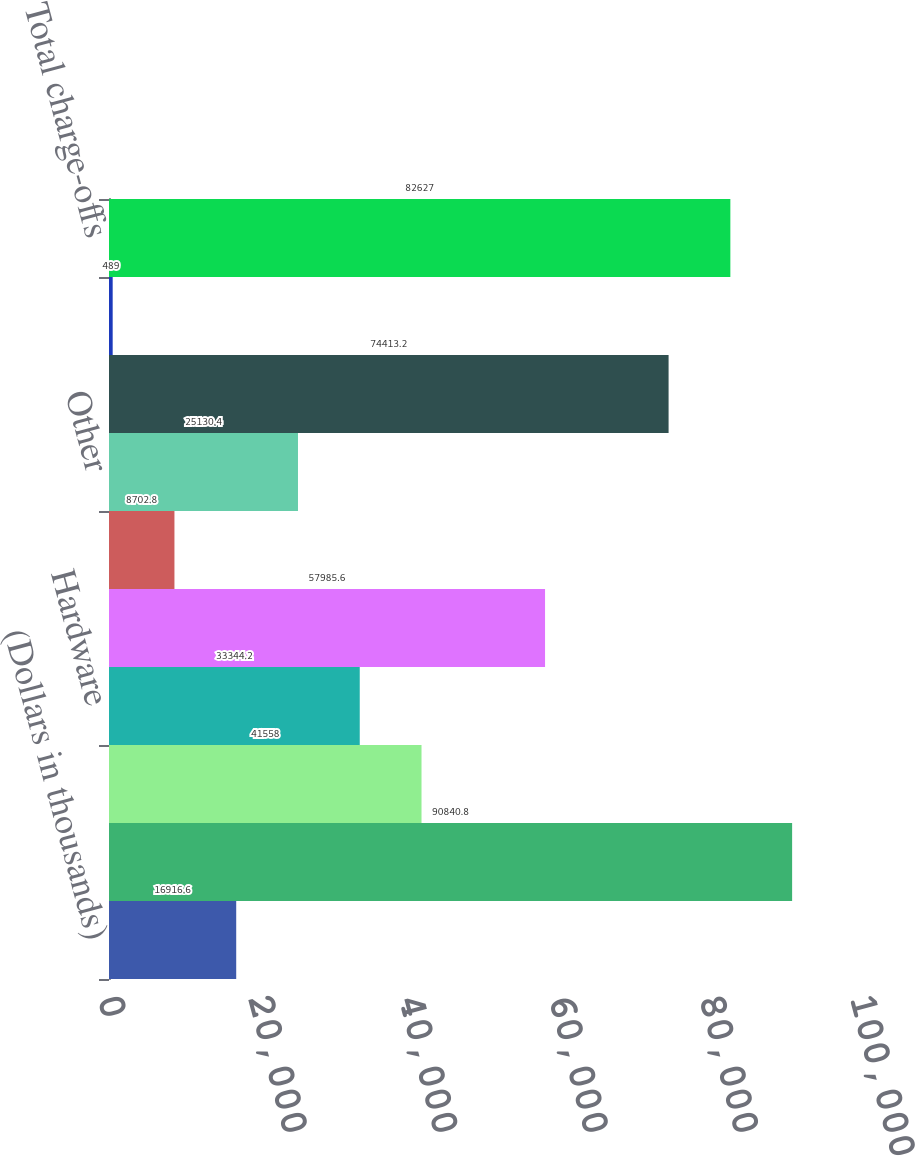Convert chart to OTSL. <chart><loc_0><loc_0><loc_500><loc_500><bar_chart><fcel>(Dollars in thousands)<fcel>Allowance for loan losses<fcel>Software<fcel>Hardware<fcel>Life science<fcel>Premium wine<fcel>Other<fcel>Total commercial loans<fcel>Consumer loans<fcel>Total charge-offs<nl><fcel>16916.6<fcel>90840.8<fcel>41558<fcel>33344.2<fcel>57985.6<fcel>8702.8<fcel>25130.4<fcel>74413.2<fcel>489<fcel>82627<nl></chart> 